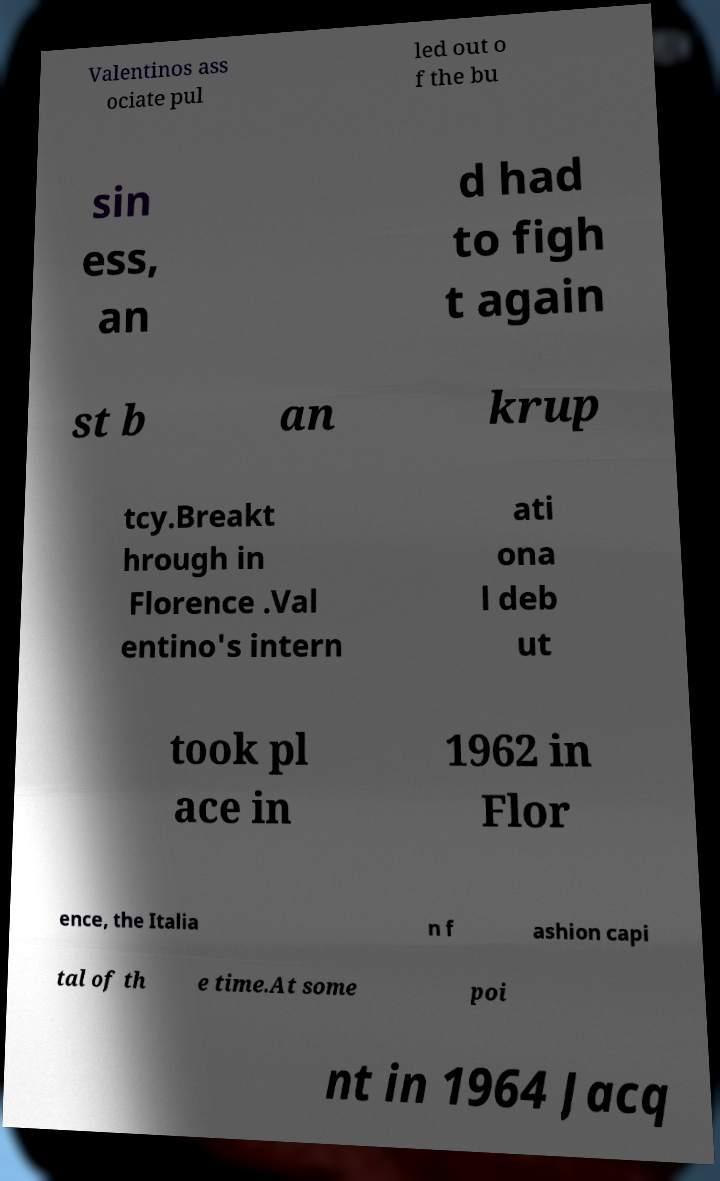Can you accurately transcribe the text from the provided image for me? Valentinos ass ociate pul led out o f the bu sin ess, an d had to figh t again st b an krup tcy.Breakt hrough in Florence .Val entino's intern ati ona l deb ut took pl ace in 1962 in Flor ence, the Italia n f ashion capi tal of th e time.At some poi nt in 1964 Jacq 